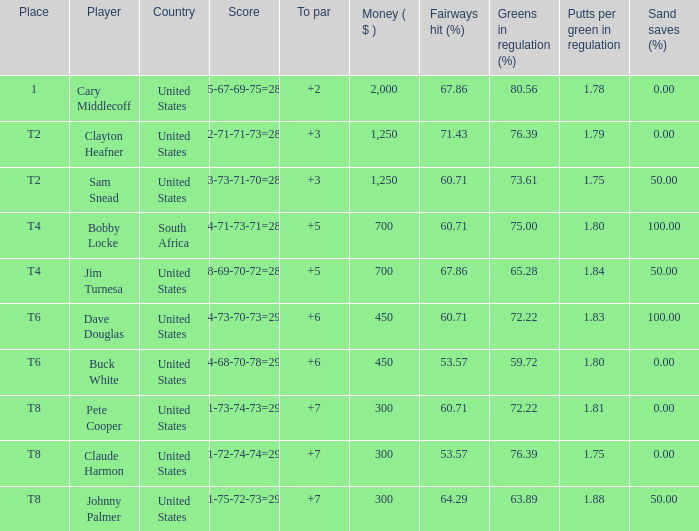I'm looking to parse the entire table for insights. Could you assist me with that? {'header': ['Place', 'Player', 'Country', 'Score', 'To par', 'Money ( $ )', 'Fairways hit (%)', 'Greens in regulation (%)', 'Putts per green in regulation', 'Sand saves (%)'], 'rows': [['1', 'Cary Middlecoff', 'United States', '75-67-69-75=286', '+2', '2,000', '67.86', '80.56', '1.78', '0.00'], ['T2', 'Clayton Heafner', 'United States', '72-71-71-73=287', '+3', '1,250', '71.43', '76.39', '1.79', '0.00'], ['T2', 'Sam Snead', 'United States', '73-73-71-70=287', '+3', '1,250', '60.71', '73.61', '1.75', '50.00'], ['T4', 'Bobby Locke', 'South Africa', '74-71-73-71=289', '+5', '700', '60.71', '75.00', '1.80', '100.00'], ['T4', 'Jim Turnesa', 'United States', '78-69-70-72=289', '+5', '700', '67.86', '65.28', '1.84', '50.00'], ['T6', 'Dave Douglas', 'United States', '74-73-70-73=290', '+6', '450', '60.71', '72.22', '1.83', '100.00'], ['T6', 'Buck White', 'United States', '74-68-70-78=290', '+6', '450', '53.57', '59.72', '1.80', '0.00'], ['T8', 'Pete Cooper', 'United States', '71-73-74-73=291', '+7', '300', '60.71', '72.22', '1.81', '0.00'], ['T8', 'Claude Harmon', 'United States', '71-72-74-74=291', '+7', '300', '53.57', '76.39', '1.75', '0.00'], ['T8', 'Johnny Palmer', 'United States', '71-75-72-73=291', '+7', '300', '64.29', '63.89', '1.88', '50.00']]} What is claude harmon's position? T8. 